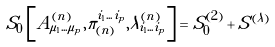<formula> <loc_0><loc_0><loc_500><loc_500>S _ { 0 } \left [ A ^ { ( n ) } _ { \mu _ { 1 } \dots \mu _ { p } } , \pi ^ { i _ { 1 } \dots i _ { p } } _ { ( n ) } , \lambda ^ { ( n ) } _ { i _ { 1 } \dots i _ { p } } \right ] = S ^ { ( 2 ) } _ { 0 } + S ^ { ( \lambda ) }</formula> 